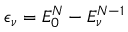<formula> <loc_0><loc_0><loc_500><loc_500>\epsilon _ { \nu } = E _ { 0 } ^ { N } - E _ { \nu } ^ { N - 1 }</formula> 